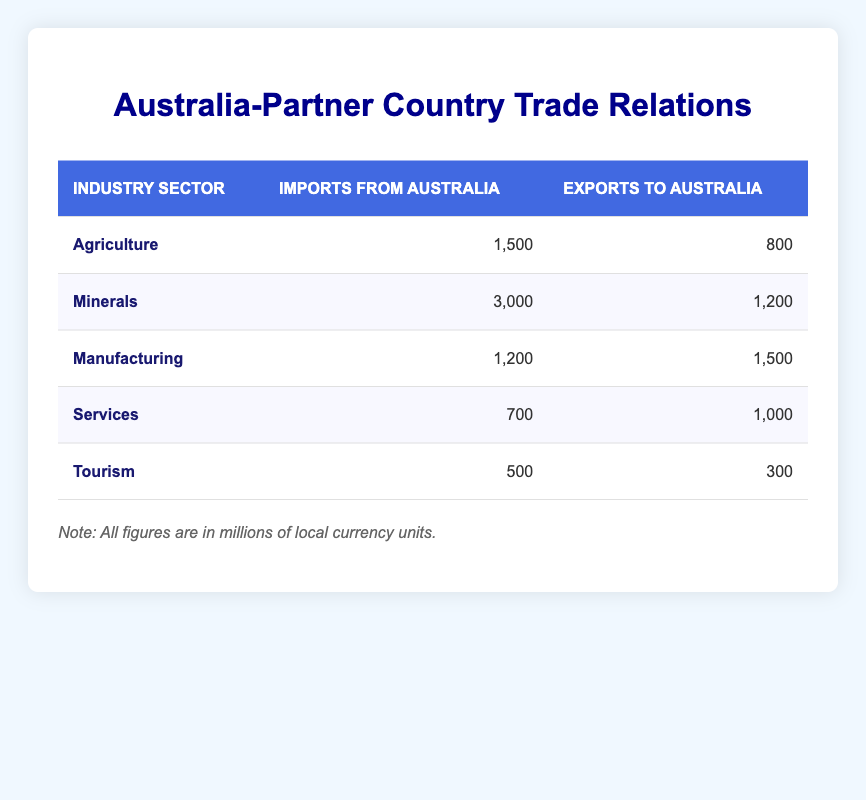What is the total amount of imports from Australia in the Agriculture sector? The table shows that the imports from Australia in the Agriculture sector amount to 1,500 million local currency units.
Answer: 1,500 How much did the country export to Australia in the Services sector? From the table, it is noted that exports to Australia in the Services sector are 1,000 million local currency units.
Answer: 1,000 Which sector had the highest imports from Australia? Looking at the table, the Minerals sector had the highest imports from Australia with 3,000 million local currency units.
Answer: Minerals What is the difference between imports and exports for the Tourism sector? In the Tourism sector, imports from Australia are 500 million, and exports to Australia are 300 million. The difference is calculated as 500 - 300 = 200 million local currency units.
Answer: 200 Is it true that the country imports more from Australia in the Manufacturing sector than it exports to Australia? The imports in the Manufacturing sector are 1,200 million, while exports to Australia are 1,500 million. Since 1,200 is less than 1,500, the statement is false.
Answer: No What is the sum of exports to Australia across all sectors? To find this, we sum the exports to Australia from each sector: 800 (Agriculture) + 1,200 (Minerals) + 1,500 (Manufacturing) + 1,000 (Services) + 300 (Tourism) = 4,800 million local currency units.
Answer: 4,800 Which sector had the lowest exports to Australia? By reviewing the table, the Tourism sector had the lowest exports to Australia, totaling 300 million local currency units.
Answer: Tourism What is the average amount of imports from Australia across all sectors? To calculate the average, we first sum the imports: 1,500 (Agriculture) + 3,000 (Minerals) + 1,200 (Manufacturing) + 700 (Services) + 500 (Tourism) = 6,900 million. There are 5 sectors, so the average is 6,900 / 5 = 1,380 million local currency units.
Answer: 1,380 In which sector is the ratio of exports to imports highest? To find this, we calculate the ratio of exports to imports for each sector: Agriculture (800/1500 = 0.533), Minerals (1200/3000 = 0.4), Manufacturing (1500/1200 = 1.25), Services (1000/700 = 1.429), Tourism (300/500 = 0.6). The highest ratio is in the Manufacturing sector, at 1.25.
Answer: Manufacturing 